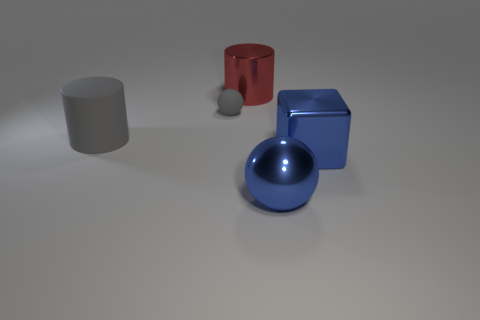What is the color of the other object that is the same shape as the big gray matte thing?
Give a very brief answer. Red. Does the blue thing behind the metal ball have the same size as the big gray matte thing?
Provide a succinct answer. Yes. What is the size of the ball that is to the right of the metal object that is behind the small matte sphere?
Your answer should be very brief. Large. Is the large block made of the same material as the large blue thing that is left of the big block?
Provide a succinct answer. Yes. Are there fewer large objects that are to the left of the block than cubes that are on the left side of the tiny gray ball?
Provide a short and direct response. No. There is a big cylinder that is the same material as the big blue block; what is its color?
Offer a very short reply. Red. Is there a large gray cylinder that is on the left side of the gray object to the left of the tiny rubber ball?
Make the answer very short. No. There is a ball that is the same size as the red metal object; what color is it?
Provide a short and direct response. Blue. What number of objects are either large gray rubber cylinders or large cylinders?
Offer a terse response. 2. How big is the sphere that is to the left of the large blue metal object in front of the large object that is right of the big blue sphere?
Keep it short and to the point. Small. 